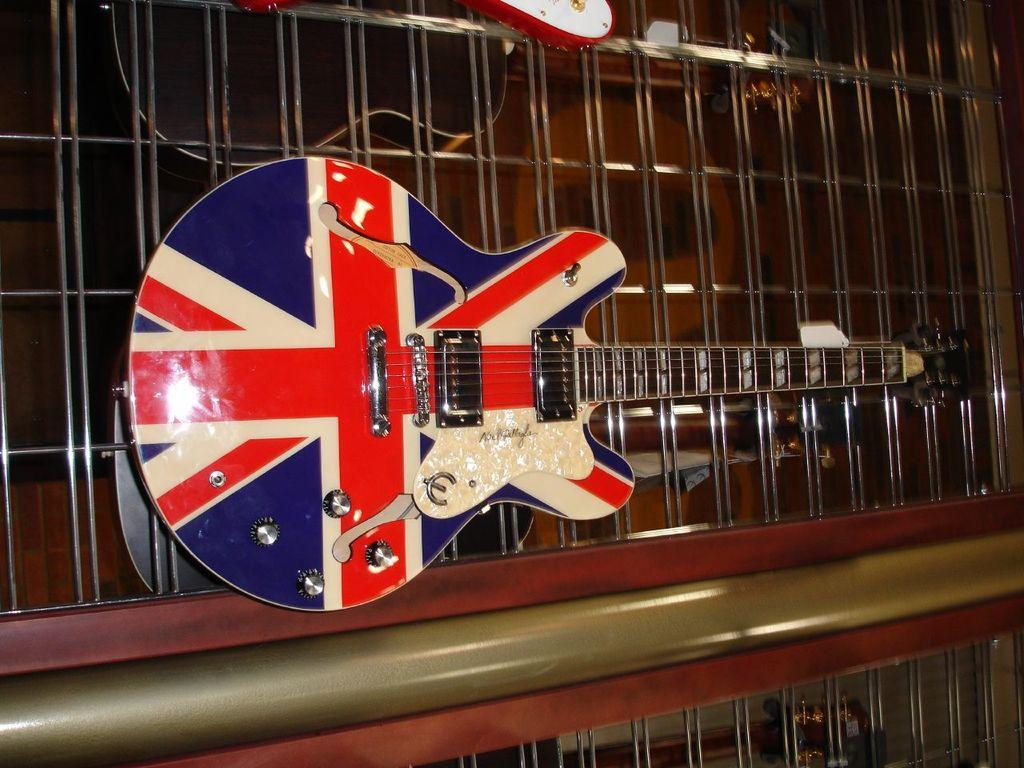What is the main subject of the image? The image depicts a musical instrument. Can you describe the colors of the musical instrument? The musical instrument has three colors: red, blue, and white. What feature of the musical instrument is mentioned in the facts? The musical instrument has strings on it. What degree is required to play the musical instrument in the image? There is no information about degrees or qualifications in the image, and the image does not depict a person playing the instrument. 